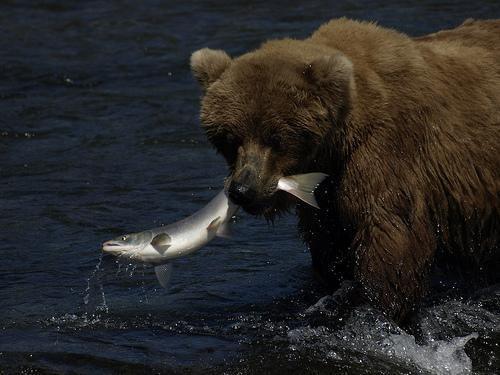How many bears are shown?
Give a very brief answer. 1. How many fish are shown?
Give a very brief answer. 1. How many fishes are pictured?
Give a very brief answer. 1. How many bears are pictured?
Give a very brief answer. 1. How many chickens did the bear catch?
Give a very brief answer. 0. 